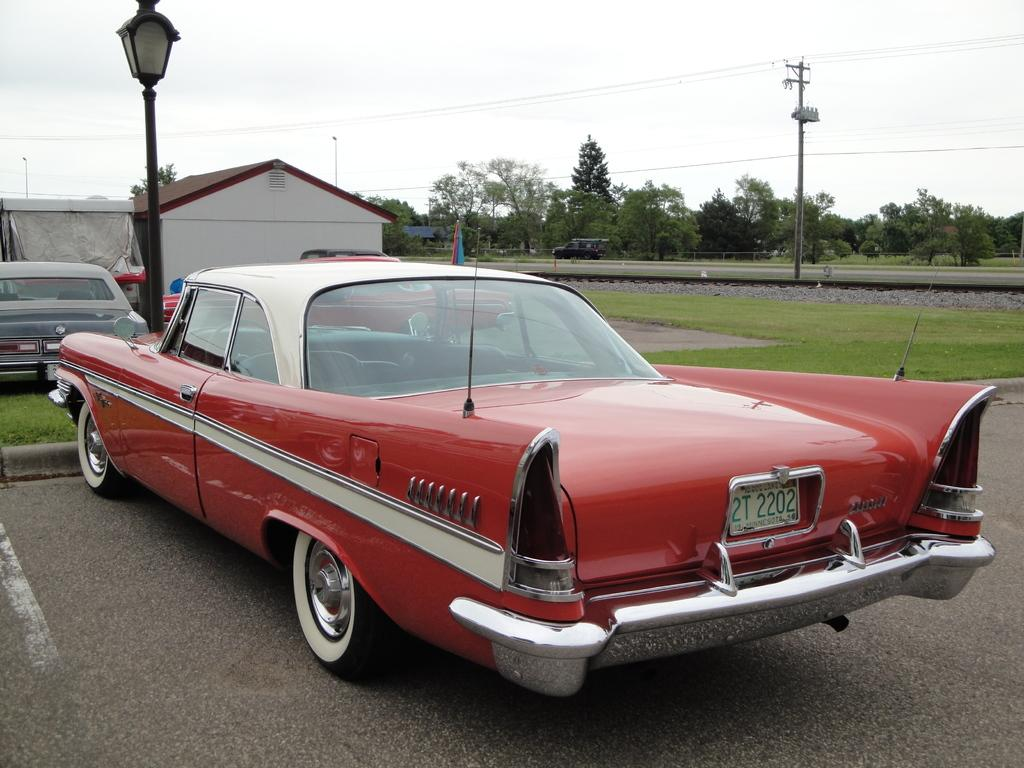What is the color of the car in the image? The car in the image is red. What can be seen in the background of the image? The sky, clouds, trees, grass, vehicles, poles, a flag, a house, and a tent are present in the background. Are there any other vehicles visible in the image besides the car? Yes, there are vehicles present in the background. What word is written on the paper that is being held by the bridge in the image? There is no bridge or paper present in the image. 